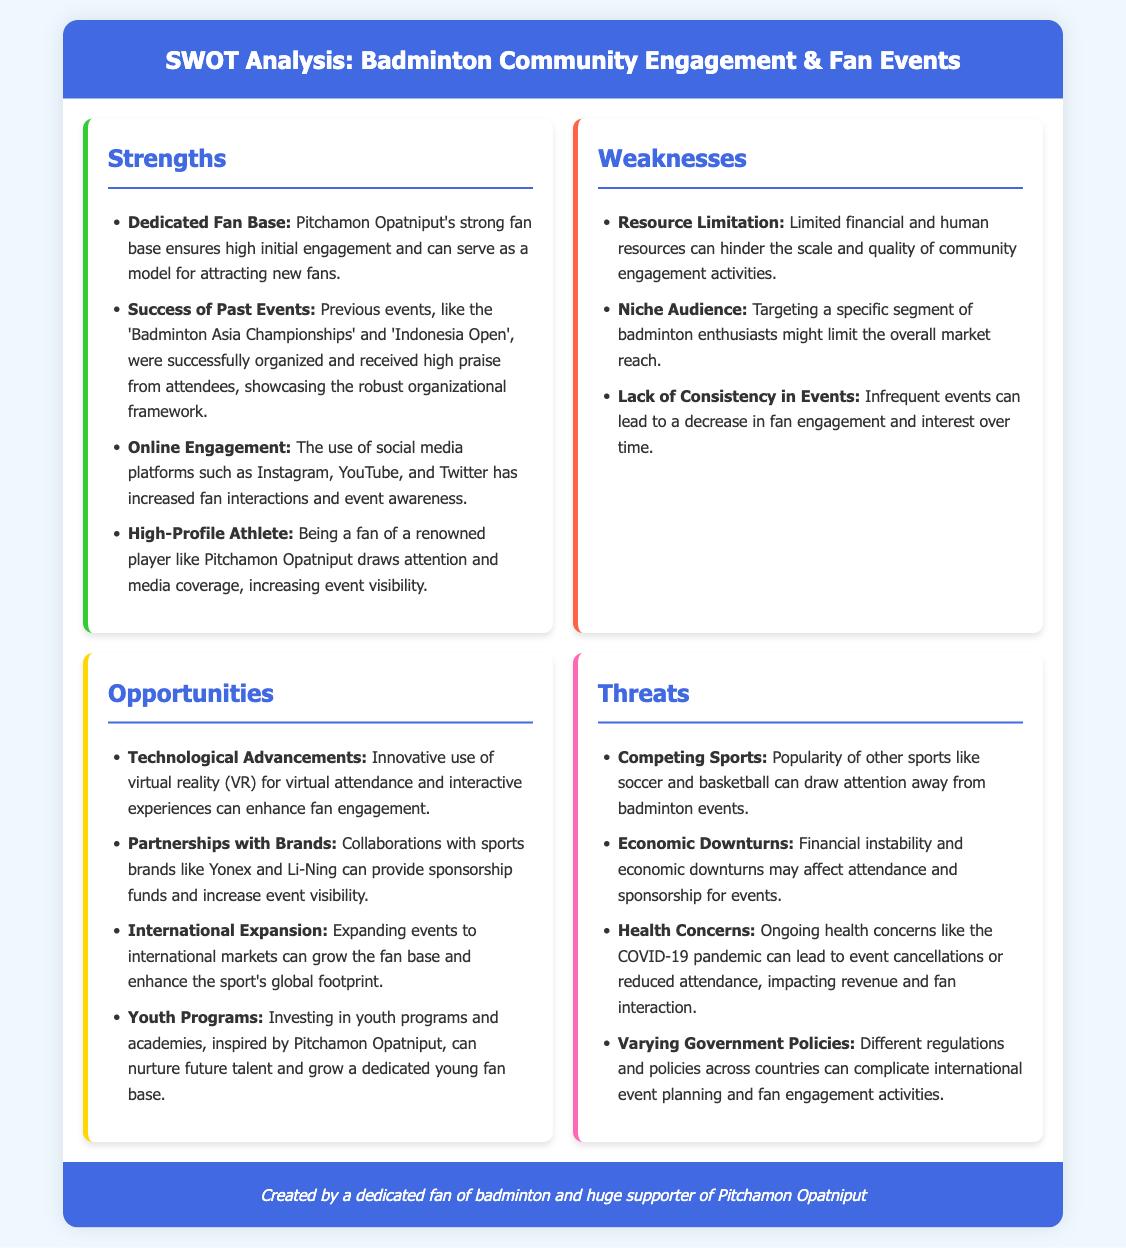What is the main title of the document? The main title is mentioned in the header of the document, which indicates the focus of the analysis.
Answer: SWOT Analysis: Badminton Community Engagement & Fan Events Who is highlighted as a high-profile athlete? The document specifies Pitchamon Opatniput as the renowned player, influencing fan engagement.
Answer: Pitchamon Opatniput What do previous events, like the 'Badminton Asia Championships', showcase? The success of past events illustrates the effective organizational framework highlighted in the strengths section.
Answer: Robust organizational framework What is a weakness concerning the audience? The document indicates the targeting of a specific segment as a limitation in reaching broader audiences.
Answer: Niche Audience Which technological aspect presents an opportunity? The text mentions virtual reality (VR) as a potential enhancement for fan engagement.
Answer: Technological Advancements What major external factor could threaten attendance? The document identifies health concerns, like the COVID-19 pandemic, as a relevant threat to events.
Answer: Health Concerns How many strengths are mentioned in the document? The document lists four specific strengths under the strengths section.
Answer: Four What is a potential area for expansion mentioned in the opportunities? The document suggests expanding events beyond current markets to broaden fan engagement.
Answer: International Expansion What color represents the threats section in the document? The style of the document uses a specific color to denote the threats section, which is pink.
Answer: Pink 